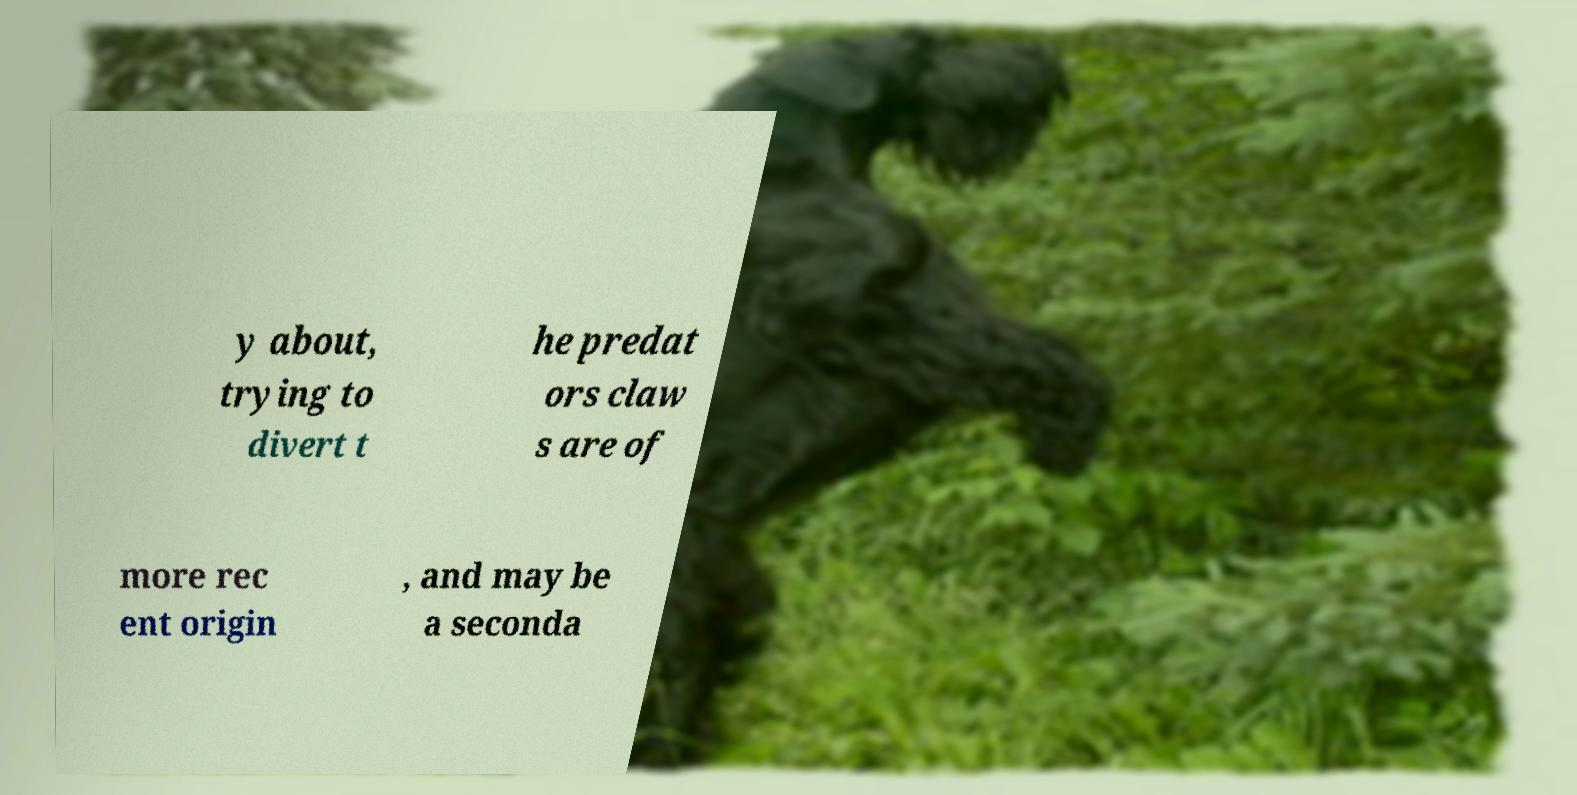There's text embedded in this image that I need extracted. Can you transcribe it verbatim? y about, trying to divert t he predat ors claw s are of more rec ent origin , and may be a seconda 